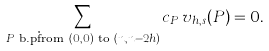Convert formula to latex. <formula><loc_0><loc_0><loc_500><loc_500>\sum _ { P \text { b.p\. from } ( 0 , 0 ) \text { to } ( n , n - 2 h ) } c _ { P } \, v _ { h , s } ( P ) = 0 .</formula> 